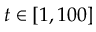<formula> <loc_0><loc_0><loc_500><loc_500>t \in [ 1 , 1 0 0 ]</formula> 